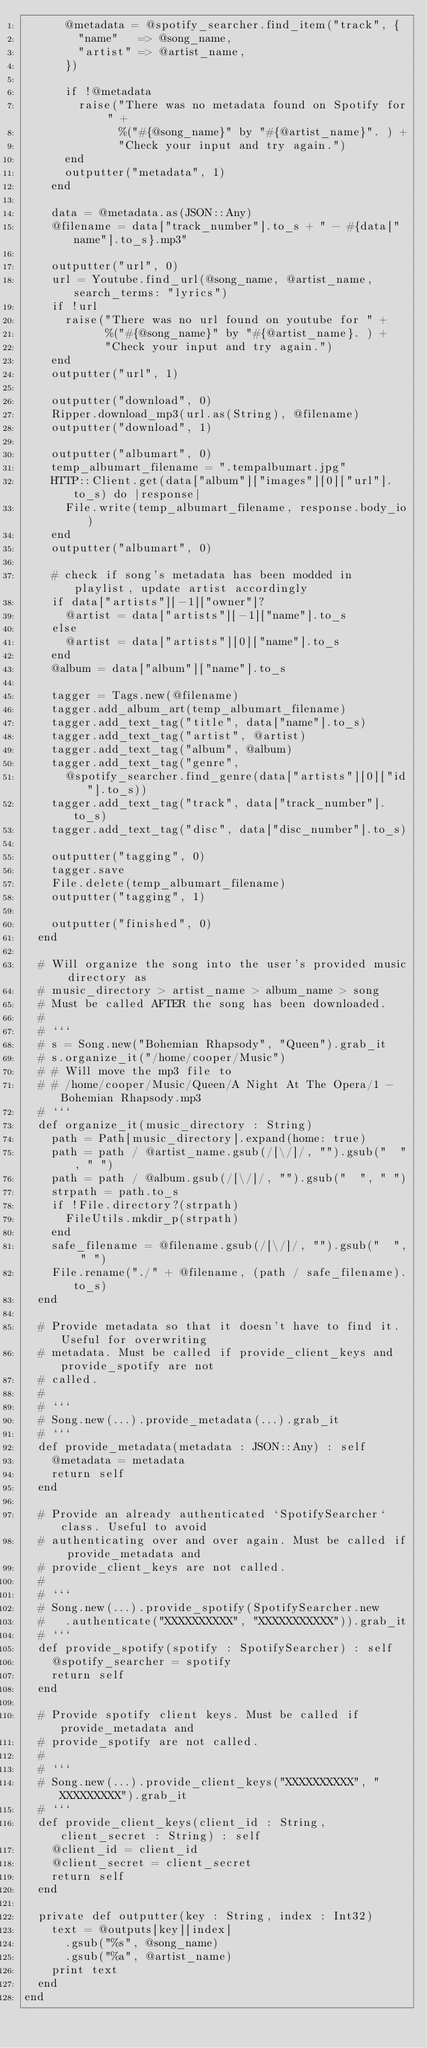<code> <loc_0><loc_0><loc_500><loc_500><_Crystal_>      @metadata = @spotify_searcher.find_item("track", {
        "name"   => @song_name,
        "artist" => @artist_name,
      })

      if !@metadata
        raise("There was no metadata found on Spotify for " +
              %("#{@song_name}" by "#{@artist_name}". ) +
              "Check your input and try again.")
      end
      outputter("metadata", 1)
    end

    data = @metadata.as(JSON::Any)
    @filename = data["track_number"].to_s + " - #{data["name"].to_s}.mp3"

    outputter("url", 0)
    url = Youtube.find_url(@song_name, @artist_name, search_terms: "lyrics")
    if !url
      raise("There was no url found on youtube for " +
            %("#{@song_name}" by "#{@artist_name}. ) +
            "Check your input and try again.")
    end
    outputter("url", 1)

    outputter("download", 0)
    Ripper.download_mp3(url.as(String), @filename)
    outputter("download", 1)

    outputter("albumart", 0)
    temp_albumart_filename = ".tempalbumart.jpg"
    HTTP::Client.get(data["album"]["images"][0]["url"].to_s) do |response|
      File.write(temp_albumart_filename, response.body_io)
    end
    outputter("albumart", 0)

    # check if song's metadata has been modded in playlist, update artist accordingly
    if data["artists"][-1]["owner"]? 
      @artist = data["artists"][-1]["name"].to_s
    else
      @artist = data["artists"][0]["name"].to_s
    end
    @album = data["album"]["name"].to_s

    tagger = Tags.new(@filename)
    tagger.add_album_art(temp_albumart_filename)
    tagger.add_text_tag("title", data["name"].to_s)
    tagger.add_text_tag("artist", @artist)
    tagger.add_text_tag("album", @album)
    tagger.add_text_tag("genre", 
      @spotify_searcher.find_genre(data["artists"][0]["id"].to_s))
    tagger.add_text_tag("track", data["track_number"].to_s)
    tagger.add_text_tag("disc", data["disc_number"].to_s)

    outputter("tagging", 0)
    tagger.save
    File.delete(temp_albumart_filename)
    outputter("tagging", 1)

    outputter("finished", 0)
  end

  # Will organize the song into the user's provided music directory as
  # music_directory > artist_name > album_name > song
  # Must be called AFTER the song has been downloaded.
  #
  # ```
  # s = Song.new("Bohemian Rhapsody", "Queen").grab_it
  # s.organize_it("/home/cooper/Music")
  # # Will move the mp3 file to
  # # /home/cooper/Music/Queen/A Night At The Opera/1 - Bohemian Rhapsody.mp3
  # ```
  def organize_it(music_directory : String)
    path = Path[music_directory].expand(home: true)
    path = path / @artist_name.gsub(/[\/]/, "").gsub("  ", " ")
    path = path / @album.gsub(/[\/]/, "").gsub("  ", " ")
    strpath = path.to_s
    if !File.directory?(strpath)
      FileUtils.mkdir_p(strpath)
    end
    safe_filename = @filename.gsub(/[\/]/, "").gsub("  ", " ")
    File.rename("./" + @filename, (path / safe_filename).to_s)
  end

  # Provide metadata so that it doesn't have to find it. Useful for overwriting
  # metadata. Must be called if provide_client_keys and provide_spotify are not
  # called.
  #
  # ```
  # Song.new(...).provide_metadata(...).grab_it
  # ```
  def provide_metadata(metadata : JSON::Any) : self
    @metadata = metadata
    return self
  end

  # Provide an already authenticated `SpotifySearcher` class. Useful to avoid
  # authenticating over and over again. Must be called if provide_metadata and
  # provide_client_keys are not called.
  #
  # ```
  # Song.new(...).provide_spotify(SpotifySearcher.new
  #   .authenticate("XXXXXXXXXX", "XXXXXXXXXXX")).grab_it
  # ```
  def provide_spotify(spotify : SpotifySearcher) : self
    @spotify_searcher = spotify
    return self
  end

  # Provide spotify client keys. Must be called if provide_metadata and
  # provide_spotify are not called.
  #
  # ```
  # Song.new(...).provide_client_keys("XXXXXXXXXX", "XXXXXXXXX").grab_it
  # ```
  def provide_client_keys(client_id : String, client_secret : String) : self
    @client_id = client_id
    @client_secret = client_secret
    return self
  end

  private def outputter(key : String, index : Int32)
    text = @outputs[key][index]
      .gsub("%s", @song_name)
      .gsub("%a", @artist_name)
    print text
  end
end
</code> 